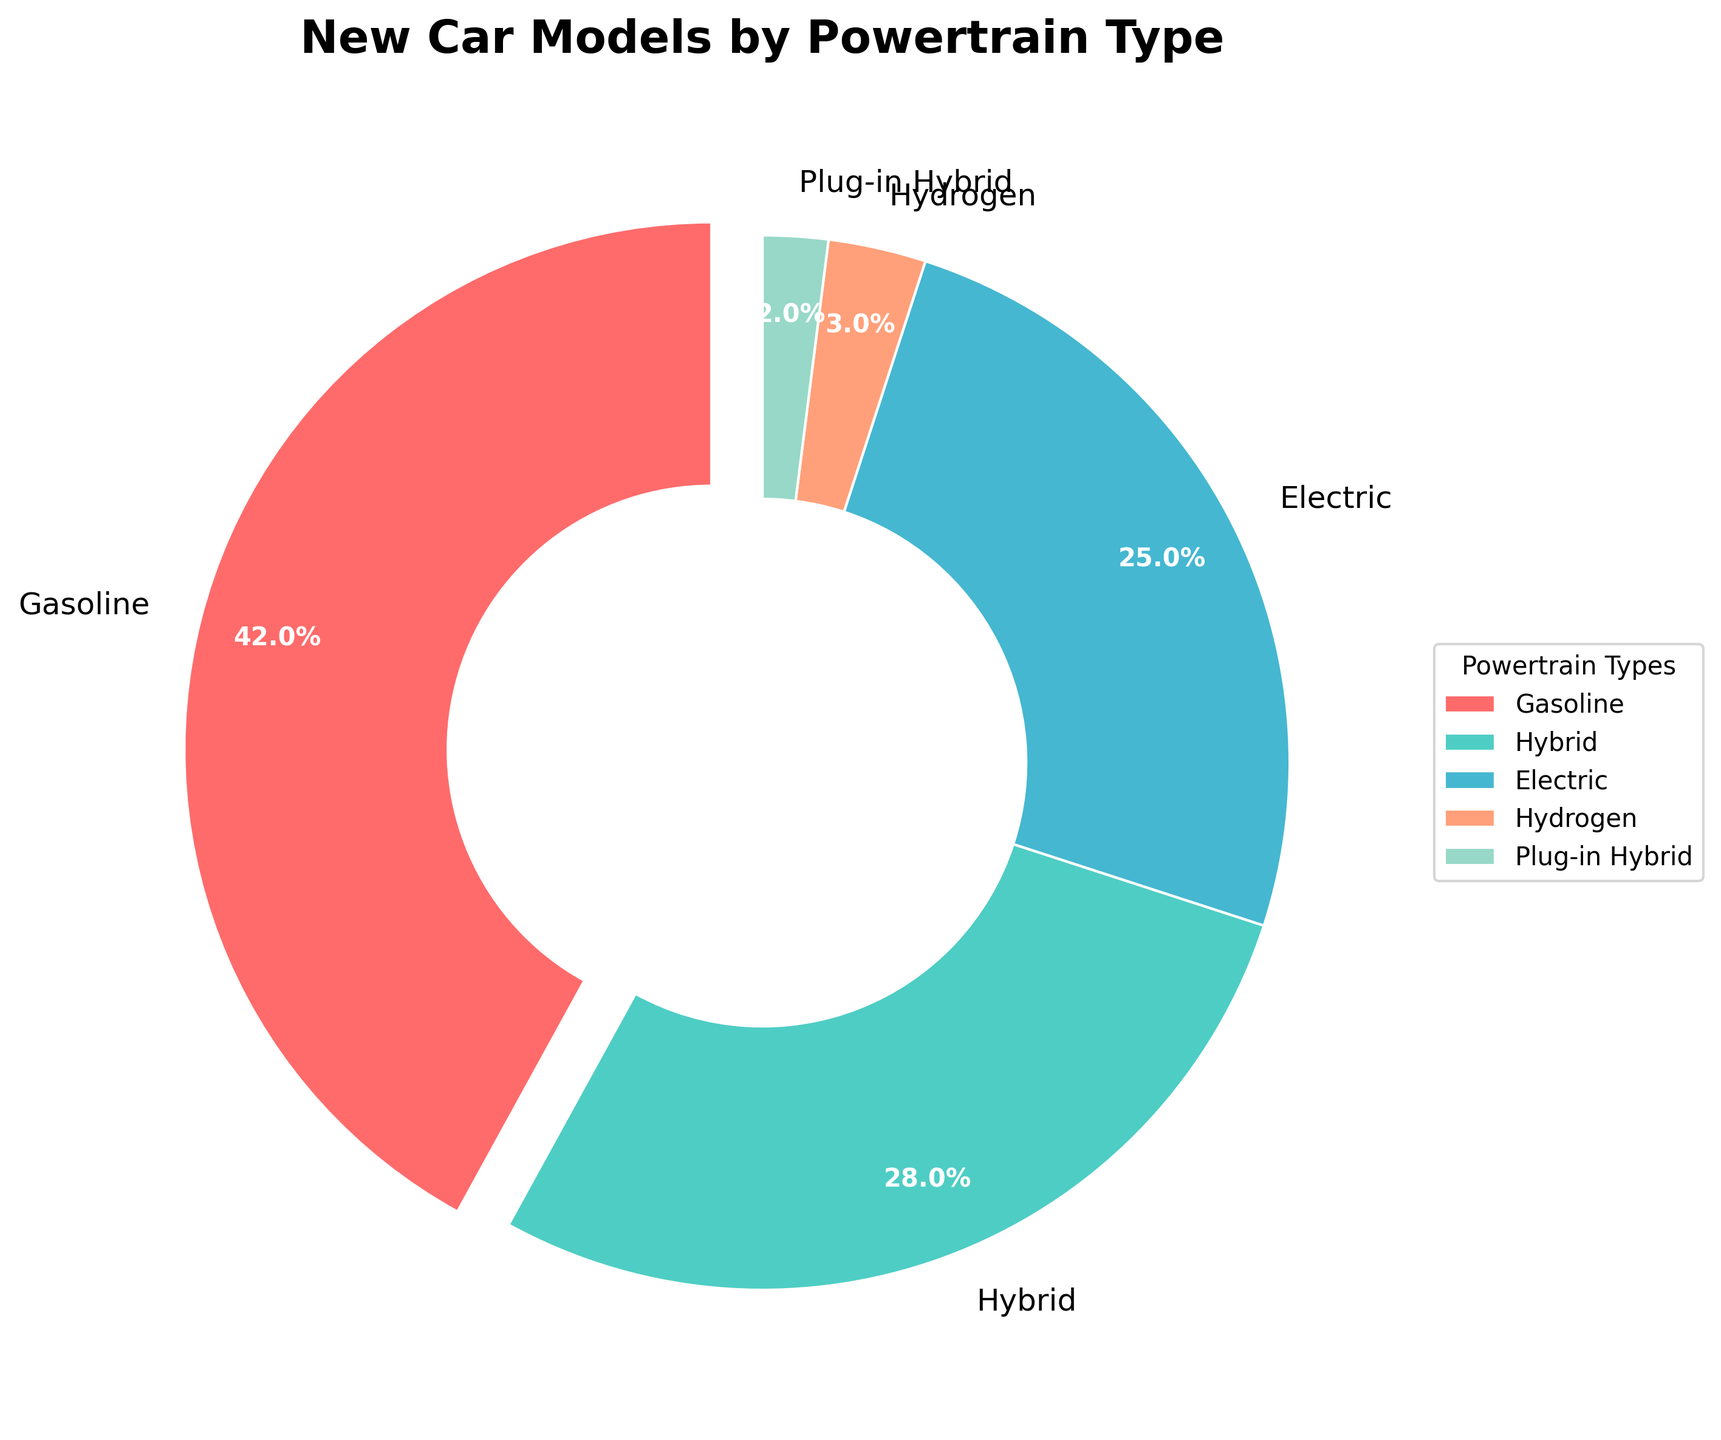What percentage of the new car models are either hybrid or electric? To find the total percentage of hybrid and electric models, add the percentages of both powertrain types: 28% (Hybrid) + 25% (Electric) = 53%.
Answer: 53% Which powertrain type has the smallest share of new car models? The pie chart shows that the hydrogen powertrain has the smallest share, with 3%.
Answer: Hydrogen How do hybrid and plug-in hybrid models compare in terms of percentage? The hybrid models account for 28%, while plug-in hybrid models account for 2%. Comparing these, hybrid models are significantly higher in percentage than plug-in hybrids.
Answer: Hybrid models have a higher percentage What is the combined percentage of gasoline and plug-in hybrid models? Add the percentages of gasoline and plug-in hybrid models: 42% (Gasoline) + 2% (Plug-in Hybrid) = 44%.
Answer: 44% Which color represents electric car models in the pie chart? The pie chart shows the electric car models in blue color.
Answer: Blue How much greater is the percentage of gasoline models compared to hydrogen models? Subtract the percentage of hydrogen models from gasoline models: 42% (Gasoline) - 3% (Hydrogen) = 39%.
Answer: 39% If the total number of new car models is 1000, how many of these models are electric? Use the percentage to find the number of electric models: 25% of 1000 = 0.25 * 1000 = 250.
Answer: 250 Which powertrain type represents less than 5% of the new car models? Both hydrogen (3%) and plug-in hybrid (2%) each represent less than 5% of the new car models.
Answer: Hydrogen and Plug-in Hybrid 